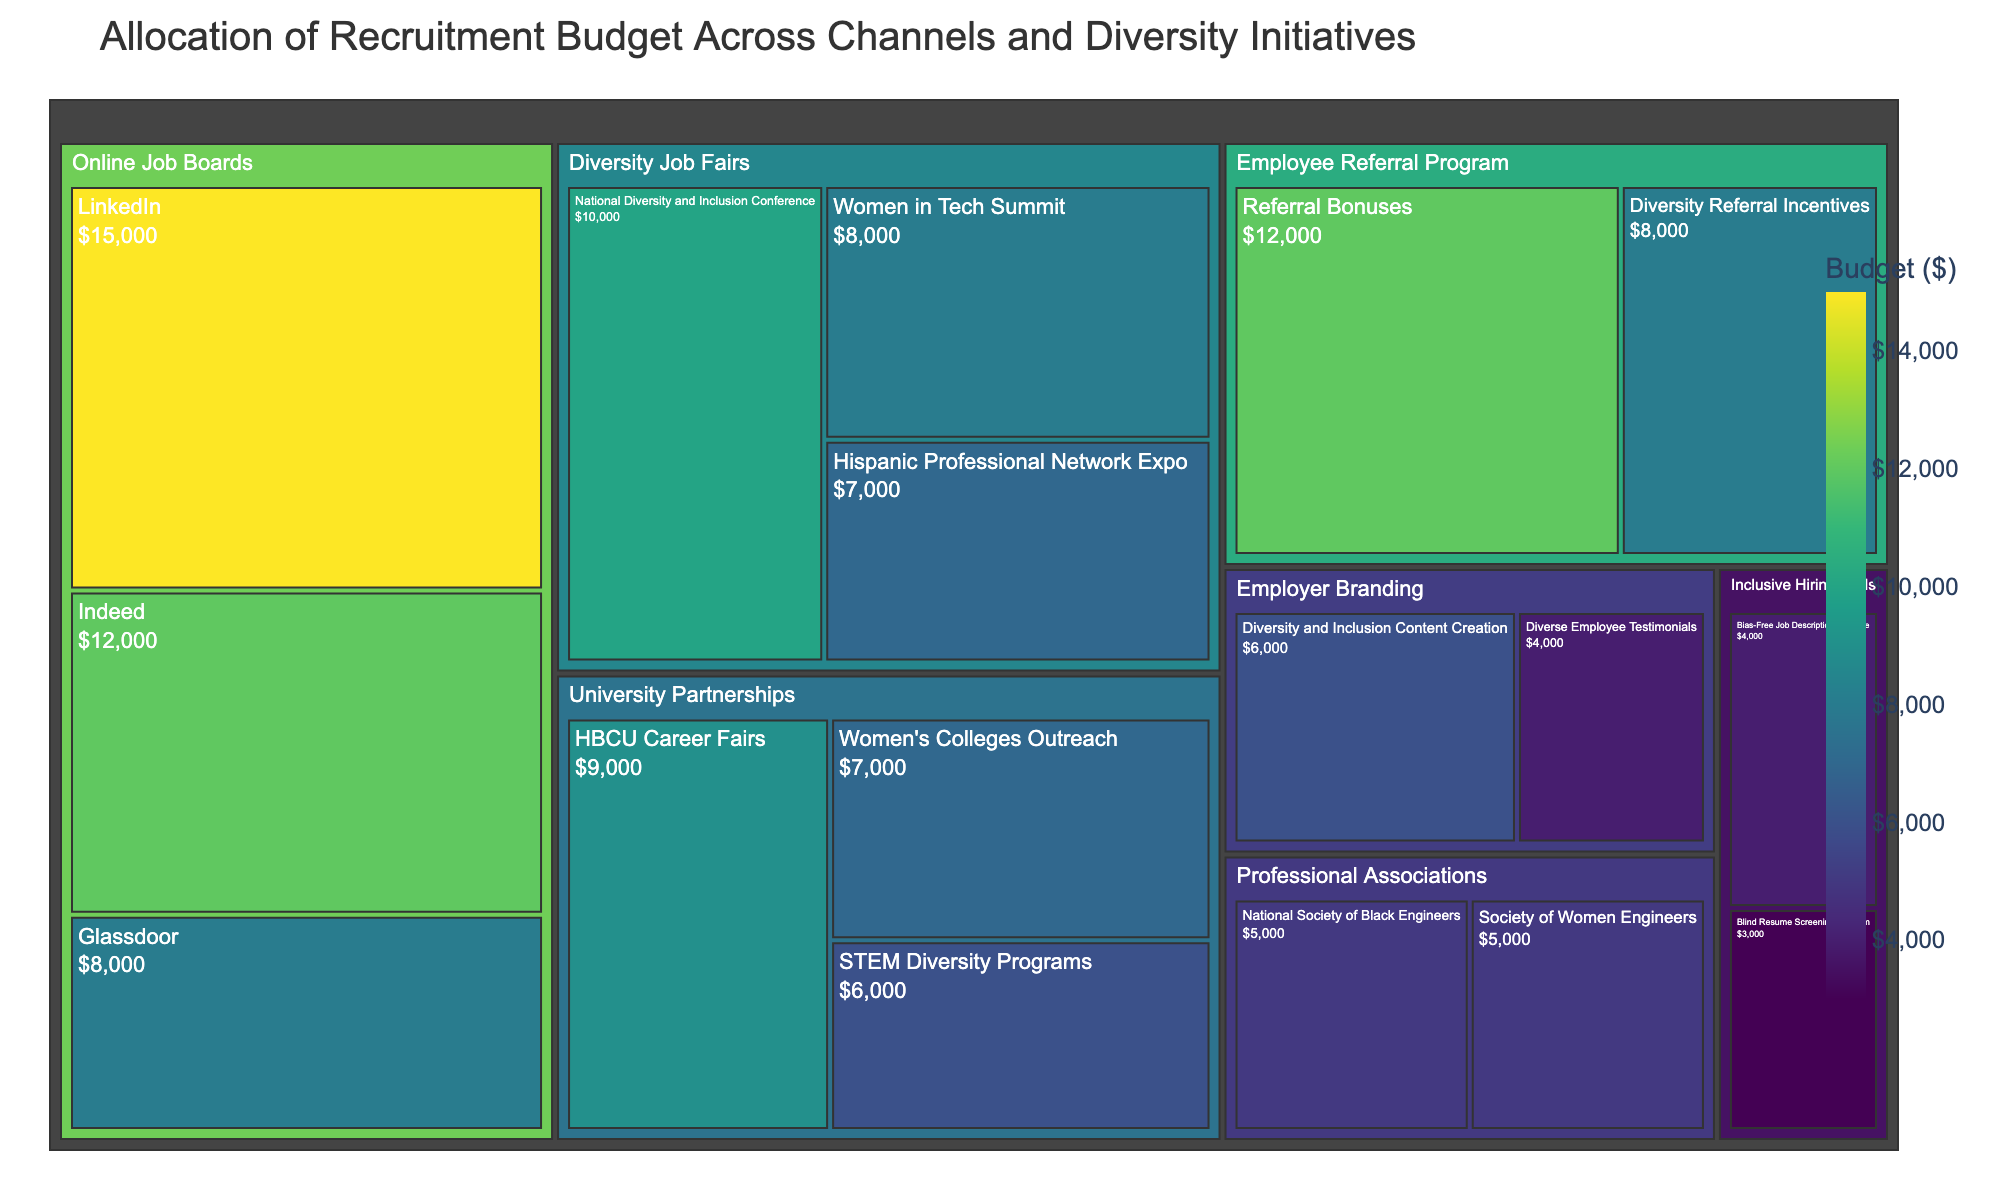What is the title of the treemap? The title is displayed at the top of the treemap, usually in a larger font size for better visibility. From the input data code, the title can be identified.
Answer: Allocation of Recruitment Budget Across Channels and Diversity Initiatives How much budget is allocated to Online Job Boards in total? Add the budget values of LinkedIn, Indeed, and Glassdoor under the Online Job Boards category. 15000 + 12000 + 8000
Answer: $35,000 Which category has the highest budget allocation? Compare the total budget values of each main category. Calculate or visually estimate the sums from subcategories within each category and identify the highest.
Answer: Online Job Boards How does the budget for Diversity Job Fairs compare to the budget for University Partnerships? Sum up the budget values of the subcategories within Diversity Job Fairs (10000 + 8000 + 7000) and University Partnerships (9000 + 7000 + 6000). Then compare the two sums.
Answer: Diversity Job Fairs have a higher budget What is the budget allocated for Inclusive Hiring Tools? Sum the budgets for the subcategories under Inclusive Hiring Tools: Bias-Free Job Description Software and Blind Resume Screening Platform. 4000 + 3000
Answer: $7,000 What is the smallest budget allocation among the subcategories? Identify the smallest budget value among all the subcategories listed in the treemap.
Answer: Blind Resume Screening Platform ($3,000) What is the budget difference between Referral Bonuses and Diversity Referral Incentives in the Employee Referral Program? Calculate the difference between the budget values for Referral Bonuses and Diversity Referral Incentives. 12000 - 8000
Answer: $4,000 Which subcategory in Diversity Job Fairs has the least budget allocation? Compare the budget values of the subcategories within Diversity Job Fairs.
Answer: Hispanic Professional Network Expo What is the average budget allocated per subcategory in Professional Associations? Sum the budgets for Society of Women Engineers and National Society of Black Engineers and divide by the number of subcategories. (5000 + 5000) / 2
Answer: $5,000 Which category has the most diverse subcategories in terms of budget allocation? Evaluate the range of budget values within each category. Look for the category where subcategories have the largest differences in their budgets.
Answer: Online Job Boards 